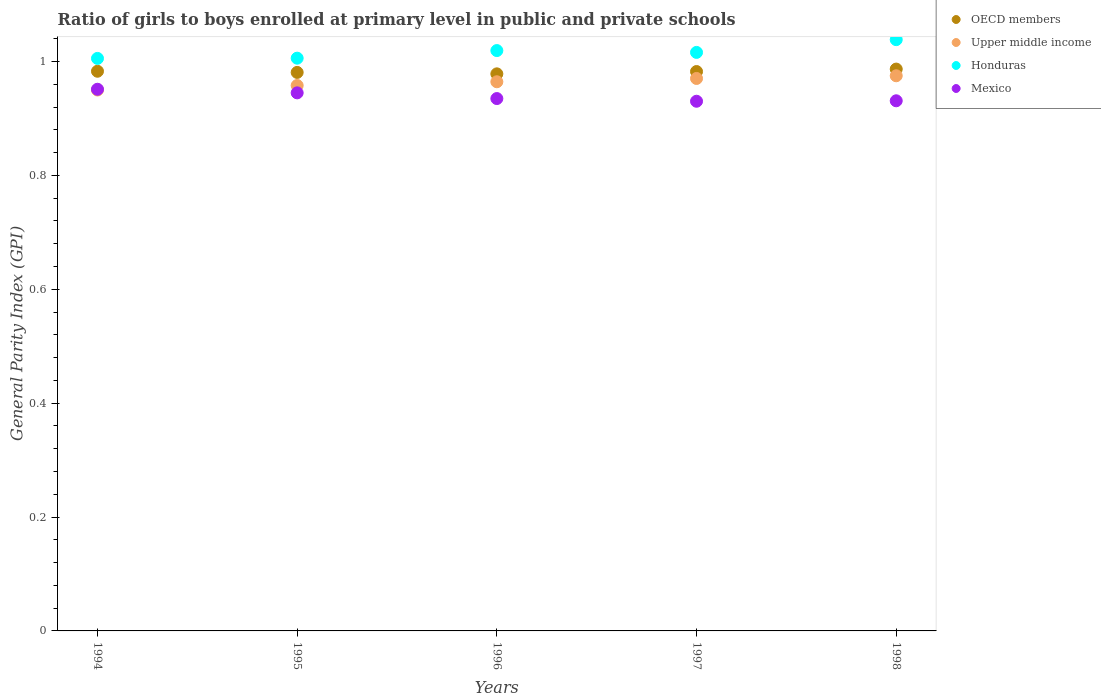How many different coloured dotlines are there?
Offer a very short reply. 4. What is the general parity index in Honduras in 1996?
Your answer should be very brief. 1.02. Across all years, what is the maximum general parity index in Honduras?
Provide a short and direct response. 1.04. Across all years, what is the minimum general parity index in Honduras?
Your response must be concise. 1.01. In which year was the general parity index in Upper middle income maximum?
Provide a succinct answer. 1998. In which year was the general parity index in Honduras minimum?
Provide a succinct answer. 1994. What is the total general parity index in Honduras in the graph?
Provide a succinct answer. 5.08. What is the difference between the general parity index in Mexico in 1994 and that in 1997?
Provide a short and direct response. 0.02. What is the difference between the general parity index in Honduras in 1998 and the general parity index in Upper middle income in 1997?
Offer a very short reply. 0.07. What is the average general parity index in Upper middle income per year?
Provide a succinct answer. 0.96. In the year 1997, what is the difference between the general parity index in Upper middle income and general parity index in OECD members?
Your response must be concise. -0.01. In how many years, is the general parity index in Upper middle income greater than 0.16?
Your response must be concise. 5. What is the ratio of the general parity index in Honduras in 1994 to that in 1998?
Ensure brevity in your answer.  0.97. Is the general parity index in Mexico in 1996 less than that in 1997?
Provide a short and direct response. No. What is the difference between the highest and the second highest general parity index in OECD members?
Ensure brevity in your answer.  0. What is the difference between the highest and the lowest general parity index in OECD members?
Offer a terse response. 0.01. Is the sum of the general parity index in OECD members in 1994 and 1997 greater than the maximum general parity index in Mexico across all years?
Offer a terse response. Yes. Is it the case that in every year, the sum of the general parity index in Honduras and general parity index in Mexico  is greater than the sum of general parity index in Upper middle income and general parity index in OECD members?
Keep it short and to the point. No. Is the general parity index in OECD members strictly greater than the general parity index in Mexico over the years?
Offer a very short reply. Yes. Is the general parity index in Mexico strictly less than the general parity index in OECD members over the years?
Provide a short and direct response. Yes. What is the difference between two consecutive major ticks on the Y-axis?
Offer a terse response. 0.2. Are the values on the major ticks of Y-axis written in scientific E-notation?
Your answer should be very brief. No. Does the graph contain grids?
Your answer should be compact. No. How many legend labels are there?
Make the answer very short. 4. What is the title of the graph?
Your answer should be very brief. Ratio of girls to boys enrolled at primary level in public and private schools. Does "Latin America(all income levels)" appear as one of the legend labels in the graph?
Keep it short and to the point. No. What is the label or title of the X-axis?
Ensure brevity in your answer.  Years. What is the label or title of the Y-axis?
Offer a very short reply. General Parity Index (GPI). What is the General Parity Index (GPI) in OECD members in 1994?
Provide a short and direct response. 0.98. What is the General Parity Index (GPI) in Upper middle income in 1994?
Give a very brief answer. 0.95. What is the General Parity Index (GPI) of Honduras in 1994?
Your answer should be very brief. 1.01. What is the General Parity Index (GPI) in Mexico in 1994?
Your answer should be compact. 0.95. What is the General Parity Index (GPI) in OECD members in 1995?
Give a very brief answer. 0.98. What is the General Parity Index (GPI) in Upper middle income in 1995?
Your answer should be very brief. 0.96. What is the General Parity Index (GPI) of Honduras in 1995?
Make the answer very short. 1.01. What is the General Parity Index (GPI) in Mexico in 1995?
Offer a very short reply. 0.94. What is the General Parity Index (GPI) in OECD members in 1996?
Make the answer very short. 0.98. What is the General Parity Index (GPI) in Upper middle income in 1996?
Make the answer very short. 0.96. What is the General Parity Index (GPI) in Honduras in 1996?
Provide a succinct answer. 1.02. What is the General Parity Index (GPI) of Mexico in 1996?
Make the answer very short. 0.93. What is the General Parity Index (GPI) in OECD members in 1997?
Your answer should be compact. 0.98. What is the General Parity Index (GPI) of Upper middle income in 1997?
Your response must be concise. 0.97. What is the General Parity Index (GPI) of Honduras in 1997?
Your answer should be very brief. 1.02. What is the General Parity Index (GPI) of Mexico in 1997?
Give a very brief answer. 0.93. What is the General Parity Index (GPI) of OECD members in 1998?
Make the answer very short. 0.99. What is the General Parity Index (GPI) in Upper middle income in 1998?
Provide a short and direct response. 0.97. What is the General Parity Index (GPI) of Honduras in 1998?
Provide a short and direct response. 1.04. What is the General Parity Index (GPI) of Mexico in 1998?
Ensure brevity in your answer.  0.93. Across all years, what is the maximum General Parity Index (GPI) in OECD members?
Give a very brief answer. 0.99. Across all years, what is the maximum General Parity Index (GPI) in Upper middle income?
Provide a succinct answer. 0.97. Across all years, what is the maximum General Parity Index (GPI) of Honduras?
Ensure brevity in your answer.  1.04. Across all years, what is the maximum General Parity Index (GPI) of Mexico?
Make the answer very short. 0.95. Across all years, what is the minimum General Parity Index (GPI) of OECD members?
Your answer should be compact. 0.98. Across all years, what is the minimum General Parity Index (GPI) in Upper middle income?
Give a very brief answer. 0.95. Across all years, what is the minimum General Parity Index (GPI) of Honduras?
Your answer should be compact. 1.01. Across all years, what is the minimum General Parity Index (GPI) of Mexico?
Ensure brevity in your answer.  0.93. What is the total General Parity Index (GPI) in OECD members in the graph?
Give a very brief answer. 4.91. What is the total General Parity Index (GPI) in Upper middle income in the graph?
Your answer should be very brief. 4.82. What is the total General Parity Index (GPI) in Honduras in the graph?
Offer a terse response. 5.08. What is the total General Parity Index (GPI) in Mexico in the graph?
Keep it short and to the point. 4.69. What is the difference between the General Parity Index (GPI) in OECD members in 1994 and that in 1995?
Your response must be concise. 0. What is the difference between the General Parity Index (GPI) in Upper middle income in 1994 and that in 1995?
Provide a succinct answer. -0.01. What is the difference between the General Parity Index (GPI) of Honduras in 1994 and that in 1995?
Your response must be concise. -0. What is the difference between the General Parity Index (GPI) in Mexico in 1994 and that in 1995?
Give a very brief answer. 0.01. What is the difference between the General Parity Index (GPI) of OECD members in 1994 and that in 1996?
Your answer should be very brief. 0. What is the difference between the General Parity Index (GPI) of Upper middle income in 1994 and that in 1996?
Your response must be concise. -0.01. What is the difference between the General Parity Index (GPI) of Honduras in 1994 and that in 1996?
Your answer should be very brief. -0.01. What is the difference between the General Parity Index (GPI) in Mexico in 1994 and that in 1996?
Your response must be concise. 0.02. What is the difference between the General Parity Index (GPI) in Upper middle income in 1994 and that in 1997?
Your answer should be very brief. -0.02. What is the difference between the General Parity Index (GPI) in Honduras in 1994 and that in 1997?
Offer a very short reply. -0.01. What is the difference between the General Parity Index (GPI) of Mexico in 1994 and that in 1997?
Give a very brief answer. 0.02. What is the difference between the General Parity Index (GPI) of OECD members in 1994 and that in 1998?
Offer a terse response. -0. What is the difference between the General Parity Index (GPI) of Upper middle income in 1994 and that in 1998?
Give a very brief answer. -0.03. What is the difference between the General Parity Index (GPI) of Honduras in 1994 and that in 1998?
Make the answer very short. -0.03. What is the difference between the General Parity Index (GPI) in Mexico in 1994 and that in 1998?
Ensure brevity in your answer.  0.02. What is the difference between the General Parity Index (GPI) in OECD members in 1995 and that in 1996?
Offer a very short reply. 0. What is the difference between the General Parity Index (GPI) of Upper middle income in 1995 and that in 1996?
Provide a short and direct response. -0.01. What is the difference between the General Parity Index (GPI) of Honduras in 1995 and that in 1996?
Provide a succinct answer. -0.01. What is the difference between the General Parity Index (GPI) of Mexico in 1995 and that in 1996?
Keep it short and to the point. 0.01. What is the difference between the General Parity Index (GPI) in OECD members in 1995 and that in 1997?
Give a very brief answer. -0. What is the difference between the General Parity Index (GPI) in Upper middle income in 1995 and that in 1997?
Ensure brevity in your answer.  -0.01. What is the difference between the General Parity Index (GPI) in Honduras in 1995 and that in 1997?
Give a very brief answer. -0.01. What is the difference between the General Parity Index (GPI) of Mexico in 1995 and that in 1997?
Offer a terse response. 0.01. What is the difference between the General Parity Index (GPI) of OECD members in 1995 and that in 1998?
Offer a terse response. -0.01. What is the difference between the General Parity Index (GPI) of Upper middle income in 1995 and that in 1998?
Give a very brief answer. -0.02. What is the difference between the General Parity Index (GPI) in Honduras in 1995 and that in 1998?
Provide a short and direct response. -0.03. What is the difference between the General Parity Index (GPI) in Mexico in 1995 and that in 1998?
Keep it short and to the point. 0.01. What is the difference between the General Parity Index (GPI) in OECD members in 1996 and that in 1997?
Ensure brevity in your answer.  -0. What is the difference between the General Parity Index (GPI) of Upper middle income in 1996 and that in 1997?
Offer a terse response. -0.01. What is the difference between the General Parity Index (GPI) of Honduras in 1996 and that in 1997?
Your response must be concise. 0. What is the difference between the General Parity Index (GPI) in Mexico in 1996 and that in 1997?
Make the answer very short. 0. What is the difference between the General Parity Index (GPI) of OECD members in 1996 and that in 1998?
Provide a short and direct response. -0.01. What is the difference between the General Parity Index (GPI) of Upper middle income in 1996 and that in 1998?
Your answer should be very brief. -0.01. What is the difference between the General Parity Index (GPI) of Honduras in 1996 and that in 1998?
Your answer should be very brief. -0.02. What is the difference between the General Parity Index (GPI) of Mexico in 1996 and that in 1998?
Your answer should be very brief. 0. What is the difference between the General Parity Index (GPI) of OECD members in 1997 and that in 1998?
Keep it short and to the point. -0. What is the difference between the General Parity Index (GPI) in Upper middle income in 1997 and that in 1998?
Give a very brief answer. -0. What is the difference between the General Parity Index (GPI) of Honduras in 1997 and that in 1998?
Make the answer very short. -0.02. What is the difference between the General Parity Index (GPI) of Mexico in 1997 and that in 1998?
Offer a very short reply. -0. What is the difference between the General Parity Index (GPI) of OECD members in 1994 and the General Parity Index (GPI) of Upper middle income in 1995?
Provide a short and direct response. 0.03. What is the difference between the General Parity Index (GPI) of OECD members in 1994 and the General Parity Index (GPI) of Honduras in 1995?
Keep it short and to the point. -0.02. What is the difference between the General Parity Index (GPI) in OECD members in 1994 and the General Parity Index (GPI) in Mexico in 1995?
Provide a succinct answer. 0.04. What is the difference between the General Parity Index (GPI) of Upper middle income in 1994 and the General Parity Index (GPI) of Honduras in 1995?
Offer a very short reply. -0.06. What is the difference between the General Parity Index (GPI) of Upper middle income in 1994 and the General Parity Index (GPI) of Mexico in 1995?
Ensure brevity in your answer.  0.01. What is the difference between the General Parity Index (GPI) of Honduras in 1994 and the General Parity Index (GPI) of Mexico in 1995?
Provide a succinct answer. 0.06. What is the difference between the General Parity Index (GPI) in OECD members in 1994 and the General Parity Index (GPI) in Upper middle income in 1996?
Give a very brief answer. 0.02. What is the difference between the General Parity Index (GPI) in OECD members in 1994 and the General Parity Index (GPI) in Honduras in 1996?
Provide a short and direct response. -0.04. What is the difference between the General Parity Index (GPI) of OECD members in 1994 and the General Parity Index (GPI) of Mexico in 1996?
Keep it short and to the point. 0.05. What is the difference between the General Parity Index (GPI) of Upper middle income in 1994 and the General Parity Index (GPI) of Honduras in 1996?
Your answer should be very brief. -0.07. What is the difference between the General Parity Index (GPI) in Upper middle income in 1994 and the General Parity Index (GPI) in Mexico in 1996?
Keep it short and to the point. 0.01. What is the difference between the General Parity Index (GPI) of Honduras in 1994 and the General Parity Index (GPI) of Mexico in 1996?
Your response must be concise. 0.07. What is the difference between the General Parity Index (GPI) of OECD members in 1994 and the General Parity Index (GPI) of Upper middle income in 1997?
Your response must be concise. 0.01. What is the difference between the General Parity Index (GPI) of OECD members in 1994 and the General Parity Index (GPI) of Honduras in 1997?
Your answer should be compact. -0.03. What is the difference between the General Parity Index (GPI) in OECD members in 1994 and the General Parity Index (GPI) in Mexico in 1997?
Offer a terse response. 0.05. What is the difference between the General Parity Index (GPI) in Upper middle income in 1994 and the General Parity Index (GPI) in Honduras in 1997?
Provide a short and direct response. -0.07. What is the difference between the General Parity Index (GPI) in Upper middle income in 1994 and the General Parity Index (GPI) in Mexico in 1997?
Ensure brevity in your answer.  0.02. What is the difference between the General Parity Index (GPI) in Honduras in 1994 and the General Parity Index (GPI) in Mexico in 1997?
Your response must be concise. 0.08. What is the difference between the General Parity Index (GPI) in OECD members in 1994 and the General Parity Index (GPI) in Upper middle income in 1998?
Ensure brevity in your answer.  0.01. What is the difference between the General Parity Index (GPI) in OECD members in 1994 and the General Parity Index (GPI) in Honduras in 1998?
Your answer should be compact. -0.06. What is the difference between the General Parity Index (GPI) in OECD members in 1994 and the General Parity Index (GPI) in Mexico in 1998?
Make the answer very short. 0.05. What is the difference between the General Parity Index (GPI) of Upper middle income in 1994 and the General Parity Index (GPI) of Honduras in 1998?
Your answer should be compact. -0.09. What is the difference between the General Parity Index (GPI) of Upper middle income in 1994 and the General Parity Index (GPI) of Mexico in 1998?
Provide a short and direct response. 0.02. What is the difference between the General Parity Index (GPI) of Honduras in 1994 and the General Parity Index (GPI) of Mexico in 1998?
Keep it short and to the point. 0.07. What is the difference between the General Parity Index (GPI) of OECD members in 1995 and the General Parity Index (GPI) of Upper middle income in 1996?
Your answer should be compact. 0.02. What is the difference between the General Parity Index (GPI) of OECD members in 1995 and the General Parity Index (GPI) of Honduras in 1996?
Your answer should be compact. -0.04. What is the difference between the General Parity Index (GPI) in OECD members in 1995 and the General Parity Index (GPI) in Mexico in 1996?
Provide a short and direct response. 0.05. What is the difference between the General Parity Index (GPI) of Upper middle income in 1995 and the General Parity Index (GPI) of Honduras in 1996?
Give a very brief answer. -0.06. What is the difference between the General Parity Index (GPI) of Upper middle income in 1995 and the General Parity Index (GPI) of Mexico in 1996?
Your answer should be compact. 0.02. What is the difference between the General Parity Index (GPI) in Honduras in 1995 and the General Parity Index (GPI) in Mexico in 1996?
Offer a very short reply. 0.07. What is the difference between the General Parity Index (GPI) of OECD members in 1995 and the General Parity Index (GPI) of Upper middle income in 1997?
Your response must be concise. 0.01. What is the difference between the General Parity Index (GPI) of OECD members in 1995 and the General Parity Index (GPI) of Honduras in 1997?
Provide a short and direct response. -0.04. What is the difference between the General Parity Index (GPI) of OECD members in 1995 and the General Parity Index (GPI) of Mexico in 1997?
Your answer should be very brief. 0.05. What is the difference between the General Parity Index (GPI) in Upper middle income in 1995 and the General Parity Index (GPI) in Honduras in 1997?
Make the answer very short. -0.06. What is the difference between the General Parity Index (GPI) in Upper middle income in 1995 and the General Parity Index (GPI) in Mexico in 1997?
Make the answer very short. 0.03. What is the difference between the General Parity Index (GPI) in Honduras in 1995 and the General Parity Index (GPI) in Mexico in 1997?
Offer a terse response. 0.08. What is the difference between the General Parity Index (GPI) of OECD members in 1995 and the General Parity Index (GPI) of Upper middle income in 1998?
Give a very brief answer. 0.01. What is the difference between the General Parity Index (GPI) of OECD members in 1995 and the General Parity Index (GPI) of Honduras in 1998?
Offer a terse response. -0.06. What is the difference between the General Parity Index (GPI) of OECD members in 1995 and the General Parity Index (GPI) of Mexico in 1998?
Your response must be concise. 0.05. What is the difference between the General Parity Index (GPI) in Upper middle income in 1995 and the General Parity Index (GPI) in Honduras in 1998?
Your answer should be very brief. -0.08. What is the difference between the General Parity Index (GPI) in Upper middle income in 1995 and the General Parity Index (GPI) in Mexico in 1998?
Your response must be concise. 0.03. What is the difference between the General Parity Index (GPI) of Honduras in 1995 and the General Parity Index (GPI) of Mexico in 1998?
Keep it short and to the point. 0.07. What is the difference between the General Parity Index (GPI) of OECD members in 1996 and the General Parity Index (GPI) of Upper middle income in 1997?
Provide a succinct answer. 0.01. What is the difference between the General Parity Index (GPI) of OECD members in 1996 and the General Parity Index (GPI) of Honduras in 1997?
Make the answer very short. -0.04. What is the difference between the General Parity Index (GPI) in OECD members in 1996 and the General Parity Index (GPI) in Mexico in 1997?
Offer a very short reply. 0.05. What is the difference between the General Parity Index (GPI) of Upper middle income in 1996 and the General Parity Index (GPI) of Honduras in 1997?
Your answer should be compact. -0.05. What is the difference between the General Parity Index (GPI) of Upper middle income in 1996 and the General Parity Index (GPI) of Mexico in 1997?
Your response must be concise. 0.03. What is the difference between the General Parity Index (GPI) of Honduras in 1996 and the General Parity Index (GPI) of Mexico in 1997?
Keep it short and to the point. 0.09. What is the difference between the General Parity Index (GPI) in OECD members in 1996 and the General Parity Index (GPI) in Upper middle income in 1998?
Offer a very short reply. 0. What is the difference between the General Parity Index (GPI) of OECD members in 1996 and the General Parity Index (GPI) of Honduras in 1998?
Your response must be concise. -0.06. What is the difference between the General Parity Index (GPI) of OECD members in 1996 and the General Parity Index (GPI) of Mexico in 1998?
Your answer should be very brief. 0.05. What is the difference between the General Parity Index (GPI) of Upper middle income in 1996 and the General Parity Index (GPI) of Honduras in 1998?
Give a very brief answer. -0.07. What is the difference between the General Parity Index (GPI) of Upper middle income in 1996 and the General Parity Index (GPI) of Mexico in 1998?
Provide a short and direct response. 0.03. What is the difference between the General Parity Index (GPI) in Honduras in 1996 and the General Parity Index (GPI) in Mexico in 1998?
Give a very brief answer. 0.09. What is the difference between the General Parity Index (GPI) in OECD members in 1997 and the General Parity Index (GPI) in Upper middle income in 1998?
Provide a short and direct response. 0.01. What is the difference between the General Parity Index (GPI) in OECD members in 1997 and the General Parity Index (GPI) in Honduras in 1998?
Keep it short and to the point. -0.06. What is the difference between the General Parity Index (GPI) in OECD members in 1997 and the General Parity Index (GPI) in Mexico in 1998?
Give a very brief answer. 0.05. What is the difference between the General Parity Index (GPI) in Upper middle income in 1997 and the General Parity Index (GPI) in Honduras in 1998?
Ensure brevity in your answer.  -0.07. What is the difference between the General Parity Index (GPI) in Upper middle income in 1997 and the General Parity Index (GPI) in Mexico in 1998?
Offer a terse response. 0.04. What is the difference between the General Parity Index (GPI) of Honduras in 1997 and the General Parity Index (GPI) of Mexico in 1998?
Make the answer very short. 0.09. What is the average General Parity Index (GPI) in OECD members per year?
Offer a terse response. 0.98. What is the average General Parity Index (GPI) in Upper middle income per year?
Ensure brevity in your answer.  0.96. What is the average General Parity Index (GPI) of Honduras per year?
Offer a very short reply. 1.02. What is the average General Parity Index (GPI) of Mexico per year?
Ensure brevity in your answer.  0.94. In the year 1994, what is the difference between the General Parity Index (GPI) in OECD members and General Parity Index (GPI) in Upper middle income?
Ensure brevity in your answer.  0.03. In the year 1994, what is the difference between the General Parity Index (GPI) of OECD members and General Parity Index (GPI) of Honduras?
Your response must be concise. -0.02. In the year 1994, what is the difference between the General Parity Index (GPI) in OECD members and General Parity Index (GPI) in Mexico?
Keep it short and to the point. 0.03. In the year 1994, what is the difference between the General Parity Index (GPI) in Upper middle income and General Parity Index (GPI) in Honduras?
Offer a very short reply. -0.06. In the year 1994, what is the difference between the General Parity Index (GPI) of Upper middle income and General Parity Index (GPI) of Mexico?
Provide a succinct answer. -0. In the year 1994, what is the difference between the General Parity Index (GPI) in Honduras and General Parity Index (GPI) in Mexico?
Provide a succinct answer. 0.05. In the year 1995, what is the difference between the General Parity Index (GPI) in OECD members and General Parity Index (GPI) in Upper middle income?
Your answer should be very brief. 0.02. In the year 1995, what is the difference between the General Parity Index (GPI) in OECD members and General Parity Index (GPI) in Honduras?
Your answer should be compact. -0.03. In the year 1995, what is the difference between the General Parity Index (GPI) of OECD members and General Parity Index (GPI) of Mexico?
Ensure brevity in your answer.  0.04. In the year 1995, what is the difference between the General Parity Index (GPI) in Upper middle income and General Parity Index (GPI) in Honduras?
Your response must be concise. -0.05. In the year 1995, what is the difference between the General Parity Index (GPI) in Upper middle income and General Parity Index (GPI) in Mexico?
Provide a succinct answer. 0.01. In the year 1995, what is the difference between the General Parity Index (GPI) of Honduras and General Parity Index (GPI) of Mexico?
Offer a terse response. 0.06. In the year 1996, what is the difference between the General Parity Index (GPI) of OECD members and General Parity Index (GPI) of Upper middle income?
Provide a succinct answer. 0.01. In the year 1996, what is the difference between the General Parity Index (GPI) in OECD members and General Parity Index (GPI) in Honduras?
Offer a very short reply. -0.04. In the year 1996, what is the difference between the General Parity Index (GPI) in OECD members and General Parity Index (GPI) in Mexico?
Provide a short and direct response. 0.04. In the year 1996, what is the difference between the General Parity Index (GPI) in Upper middle income and General Parity Index (GPI) in Honduras?
Ensure brevity in your answer.  -0.05. In the year 1996, what is the difference between the General Parity Index (GPI) in Upper middle income and General Parity Index (GPI) in Mexico?
Your answer should be compact. 0.03. In the year 1996, what is the difference between the General Parity Index (GPI) in Honduras and General Parity Index (GPI) in Mexico?
Your response must be concise. 0.08. In the year 1997, what is the difference between the General Parity Index (GPI) in OECD members and General Parity Index (GPI) in Upper middle income?
Give a very brief answer. 0.01. In the year 1997, what is the difference between the General Parity Index (GPI) of OECD members and General Parity Index (GPI) of Honduras?
Your answer should be compact. -0.03. In the year 1997, what is the difference between the General Parity Index (GPI) of OECD members and General Parity Index (GPI) of Mexico?
Make the answer very short. 0.05. In the year 1997, what is the difference between the General Parity Index (GPI) in Upper middle income and General Parity Index (GPI) in Honduras?
Offer a terse response. -0.05. In the year 1997, what is the difference between the General Parity Index (GPI) in Upper middle income and General Parity Index (GPI) in Mexico?
Your answer should be compact. 0.04. In the year 1997, what is the difference between the General Parity Index (GPI) of Honduras and General Parity Index (GPI) of Mexico?
Your answer should be very brief. 0.09. In the year 1998, what is the difference between the General Parity Index (GPI) in OECD members and General Parity Index (GPI) in Upper middle income?
Ensure brevity in your answer.  0.01. In the year 1998, what is the difference between the General Parity Index (GPI) in OECD members and General Parity Index (GPI) in Honduras?
Your answer should be compact. -0.05. In the year 1998, what is the difference between the General Parity Index (GPI) in OECD members and General Parity Index (GPI) in Mexico?
Your response must be concise. 0.06. In the year 1998, what is the difference between the General Parity Index (GPI) in Upper middle income and General Parity Index (GPI) in Honduras?
Give a very brief answer. -0.06. In the year 1998, what is the difference between the General Parity Index (GPI) of Upper middle income and General Parity Index (GPI) of Mexico?
Give a very brief answer. 0.04. In the year 1998, what is the difference between the General Parity Index (GPI) of Honduras and General Parity Index (GPI) of Mexico?
Provide a succinct answer. 0.11. What is the ratio of the General Parity Index (GPI) in OECD members in 1994 to that in 1995?
Your answer should be compact. 1. What is the ratio of the General Parity Index (GPI) in Upper middle income in 1994 to that in 1995?
Your answer should be compact. 0.99. What is the ratio of the General Parity Index (GPI) of OECD members in 1994 to that in 1996?
Offer a terse response. 1. What is the ratio of the General Parity Index (GPI) of Honduras in 1994 to that in 1996?
Give a very brief answer. 0.99. What is the ratio of the General Parity Index (GPI) in Mexico in 1994 to that in 1996?
Make the answer very short. 1.02. What is the ratio of the General Parity Index (GPI) of Upper middle income in 1994 to that in 1997?
Provide a succinct answer. 0.98. What is the ratio of the General Parity Index (GPI) of Honduras in 1994 to that in 1997?
Provide a short and direct response. 0.99. What is the ratio of the General Parity Index (GPI) of Mexico in 1994 to that in 1997?
Offer a terse response. 1.02. What is the ratio of the General Parity Index (GPI) of Upper middle income in 1994 to that in 1998?
Your answer should be compact. 0.97. What is the ratio of the General Parity Index (GPI) of Honduras in 1994 to that in 1998?
Your answer should be compact. 0.97. What is the ratio of the General Parity Index (GPI) in Mexico in 1994 to that in 1998?
Ensure brevity in your answer.  1.02. What is the ratio of the General Parity Index (GPI) of OECD members in 1995 to that in 1996?
Your answer should be compact. 1. What is the ratio of the General Parity Index (GPI) of Upper middle income in 1995 to that in 1996?
Give a very brief answer. 0.99. What is the ratio of the General Parity Index (GPI) in Honduras in 1995 to that in 1996?
Your answer should be very brief. 0.99. What is the ratio of the General Parity Index (GPI) in Mexico in 1995 to that in 1996?
Give a very brief answer. 1.01. What is the ratio of the General Parity Index (GPI) of OECD members in 1995 to that in 1997?
Offer a very short reply. 1. What is the ratio of the General Parity Index (GPI) of Upper middle income in 1995 to that in 1997?
Offer a terse response. 0.99. What is the ratio of the General Parity Index (GPI) of Honduras in 1995 to that in 1997?
Your response must be concise. 0.99. What is the ratio of the General Parity Index (GPI) in Mexico in 1995 to that in 1997?
Your answer should be compact. 1.02. What is the ratio of the General Parity Index (GPI) in Upper middle income in 1995 to that in 1998?
Your response must be concise. 0.98. What is the ratio of the General Parity Index (GPI) of Honduras in 1995 to that in 1998?
Your answer should be very brief. 0.97. What is the ratio of the General Parity Index (GPI) of Mexico in 1995 to that in 1998?
Provide a succinct answer. 1.01. What is the ratio of the General Parity Index (GPI) of OECD members in 1996 to that in 1997?
Offer a terse response. 1. What is the ratio of the General Parity Index (GPI) in Mexico in 1996 to that in 1997?
Provide a short and direct response. 1.01. What is the ratio of the General Parity Index (GPI) of Upper middle income in 1996 to that in 1998?
Make the answer very short. 0.99. What is the ratio of the General Parity Index (GPI) of Honduras in 1996 to that in 1998?
Provide a succinct answer. 0.98. What is the ratio of the General Parity Index (GPI) in Mexico in 1996 to that in 1998?
Provide a succinct answer. 1. What is the ratio of the General Parity Index (GPI) in Upper middle income in 1997 to that in 1998?
Offer a terse response. 1. What is the ratio of the General Parity Index (GPI) of Honduras in 1997 to that in 1998?
Provide a succinct answer. 0.98. What is the ratio of the General Parity Index (GPI) of Mexico in 1997 to that in 1998?
Provide a succinct answer. 1. What is the difference between the highest and the second highest General Parity Index (GPI) in OECD members?
Keep it short and to the point. 0. What is the difference between the highest and the second highest General Parity Index (GPI) in Upper middle income?
Offer a terse response. 0. What is the difference between the highest and the second highest General Parity Index (GPI) of Honduras?
Give a very brief answer. 0.02. What is the difference between the highest and the second highest General Parity Index (GPI) in Mexico?
Provide a short and direct response. 0.01. What is the difference between the highest and the lowest General Parity Index (GPI) of OECD members?
Offer a terse response. 0.01. What is the difference between the highest and the lowest General Parity Index (GPI) of Upper middle income?
Your answer should be compact. 0.03. What is the difference between the highest and the lowest General Parity Index (GPI) of Honduras?
Offer a very short reply. 0.03. What is the difference between the highest and the lowest General Parity Index (GPI) of Mexico?
Your answer should be very brief. 0.02. 